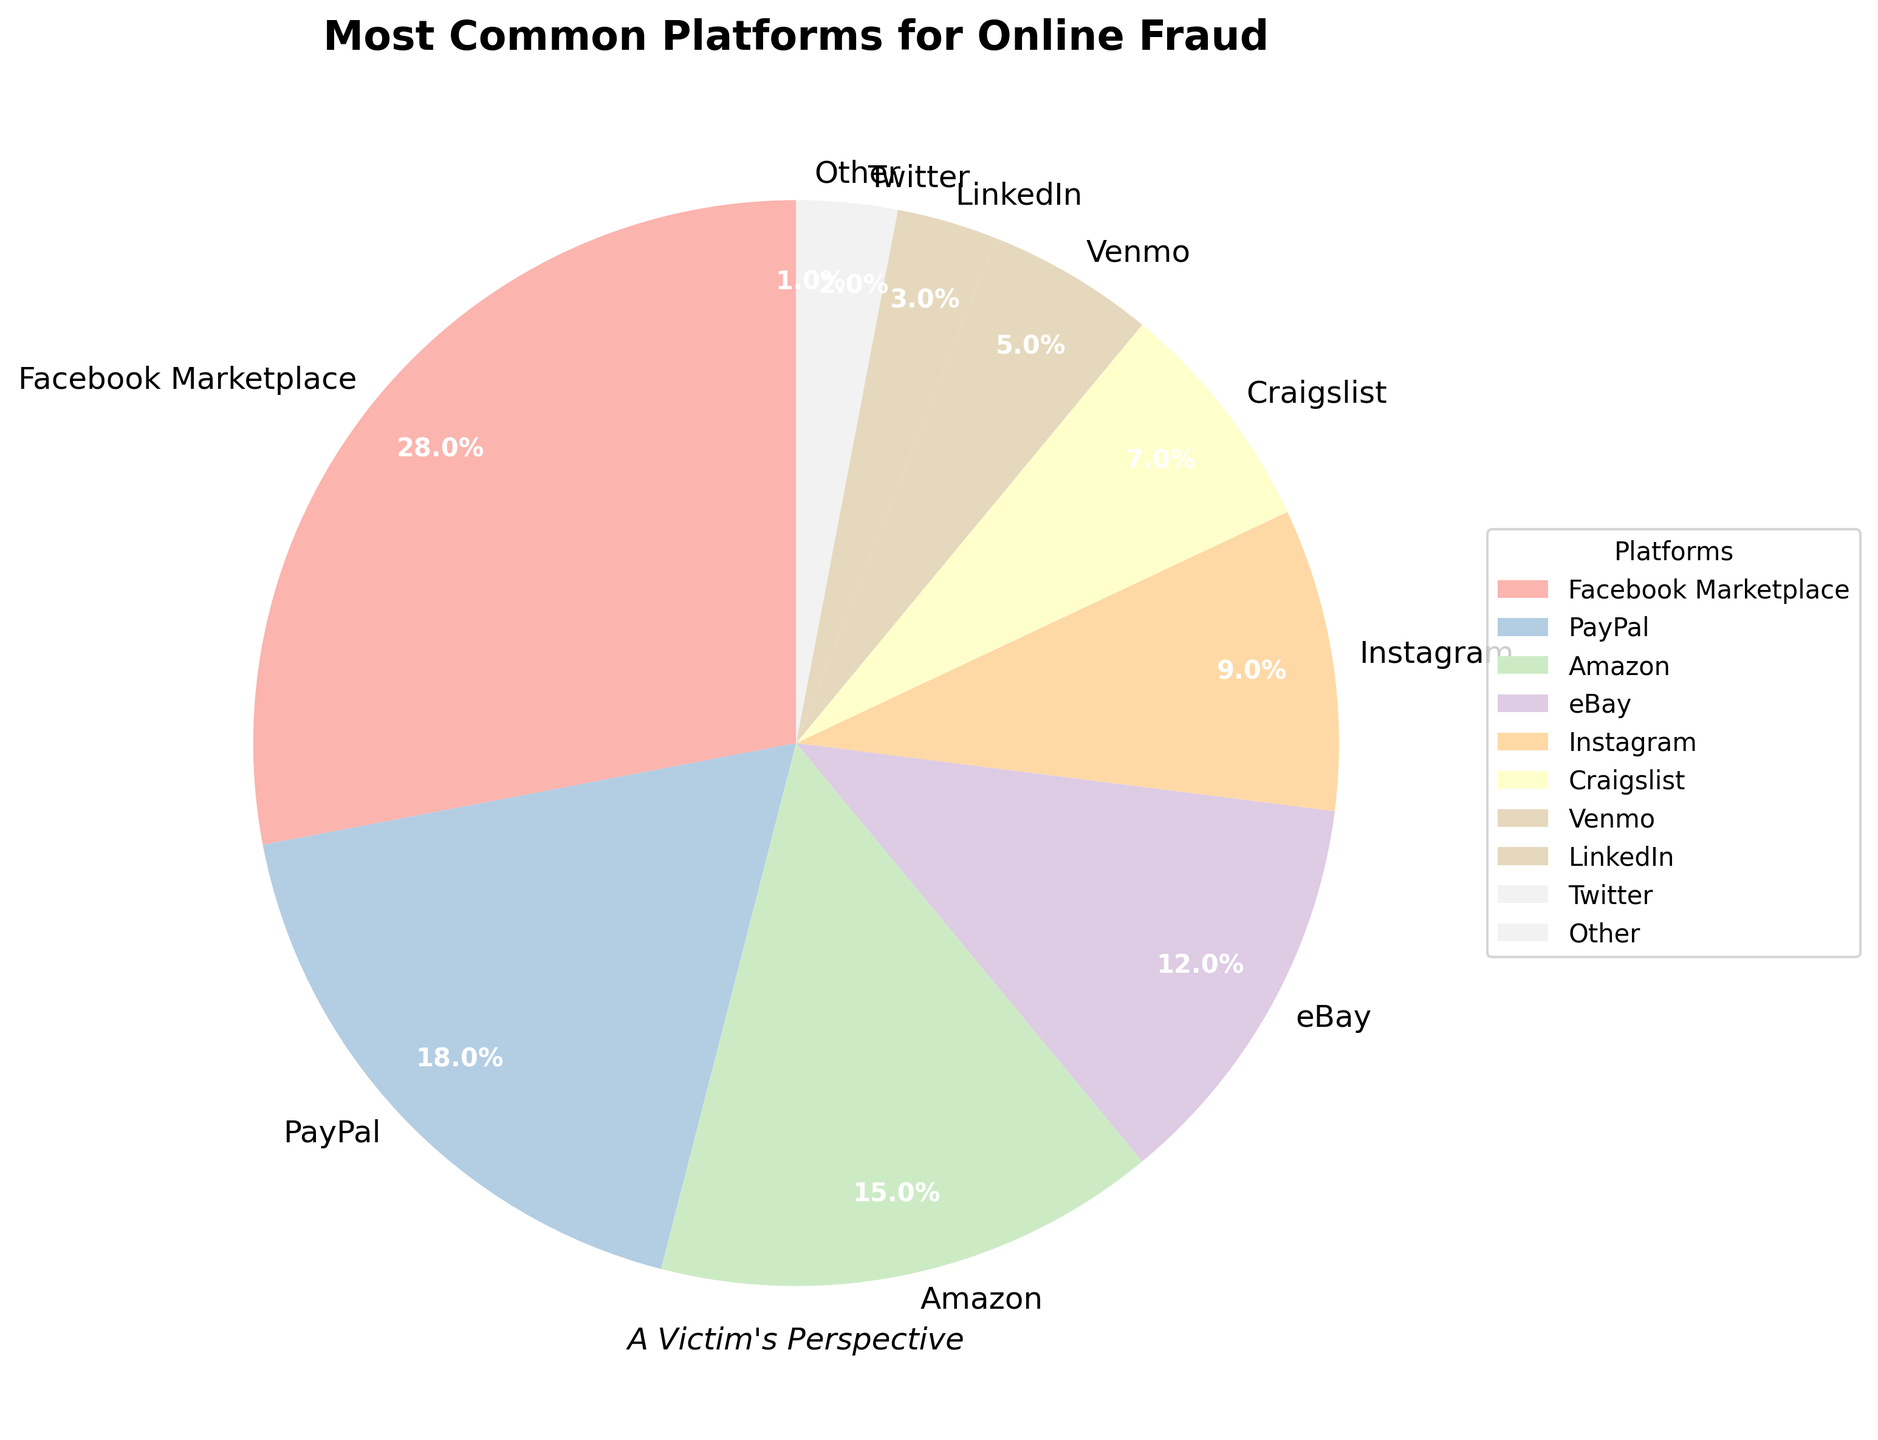What's the largest platform for online fraud according to the chart? By looking at the pie chart, the largest section represents the platform with the highest percentage. According to the chart, Facebook Marketplace has the largest section.
Answer: Facebook Marketplace Which platform accounts for a higher percentage of online fraud, eBay or Amazon? Comparing the sizes of the pie chart sections for eBay and Amazon, the section for Amazon is larger than that for eBay. According to the chart, Amazon accounts for 15% while eBay accounts for 12%.
Answer: Amazon What is the combined percentage of online fraud for Facebook Marketplace, PayPal, and Amazon? To find the combined percentage, sum the percentages of Facebook Marketplace, PayPal, and Amazon: 28% + 18% + 15% = 61%.
Answer: 61% Which platform has the smallest percentage of online fraud? The smallest section of the pie chart represents the platform with the lowest percentage. According to the chart, platforms under 'Other' have the smallest section with 1%.
Answer: Other If we combine the percentages of Craigslist, Venmo, LinkedIn, and Twitter, does it exceed the percentage of Facebook Marketplace? Summing the percentages of Craigslist (7%), Venmo (5%), LinkedIn (3%), and Twitter (2%) gives: 7% + 5% + 3% + 2% = 17%. Since 17% is less than 28%, it does not exceed Facebook Marketplace's percentage.
Answer: No Which platform is halfway through the list if the platforms are ranked by their percentage of online fraud? Ranking by percentage: Facebook Marketplace (28%), PayPal (18%), Amazon (15%), eBay (12%), Instagram (9%), Craigslist (7%), Venmo (5%), LinkedIn (3%), Twitter (2%), Other (1%). The median platform (5th in this 10-platform list) is Instagram.
Answer: Instagram What is the color used for PayPal in the pie chart? Each section of the pie chart is colored differently, and PayPal falls into the second largest section. According to the palette, pastel colors are used in sequence.
Answer: (Cannot be determined without visual context but it's a pastel color) 